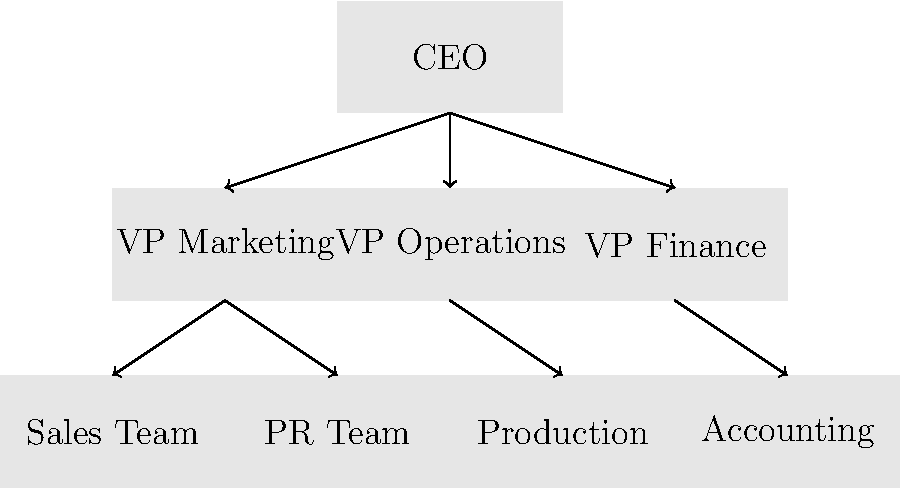As an aspiring entrepreneur interested in economic freedom, you're analyzing different business structures. The organizational chart above represents which type of business structure, and how does it align with the principle of limited government interference? To answer this question, let's analyze the organizational chart step-by-step:

1. Structure: The chart shows a hierarchical structure with clear levels of authority.
   - At the top is a single CEO
   - Below are three VP positions (Marketing, Operations, Finance)
   - Under each VP are specialized teams

2. Characteristics of this structure:
   - Centralized decision-making
   - Clear chain of command
   - Specialized departments

3. Business structure identification:
   This structure most closely resembles a corporation. Corporations are characterized by:
   - Hierarchical management
   - Separation of ownership (shareholders) and management (executives)
   - Limited liability for owners

4. Alignment with limited government interference:
   - Corporations provide a structure that allows for significant economic activity with minimal direct government involvement in day-to-day operations.
   - They operate under a set of established laws but have freedom in internal decision-making.
   - The limited liability aspect encourages risk-taking and entrepreneurship, as personal assets are protected.

5. Relevance to economic freedom:
   - Corporations can raise capital through stock issuance, enabling large-scale economic activities.
   - They can operate across state and national boundaries, fostering free trade.
   - The structure allows for efficient resource allocation and specialization, key aspects of a free market economy.

In summary, this corporate structure aligns with the principles of economic freedom and limited government interference by providing a framework for large-scale private enterprise within a system of general rules, rather than direct government control.
Answer: Corporation; it allows for large-scale private enterprise with minimal government involvement in operations. 